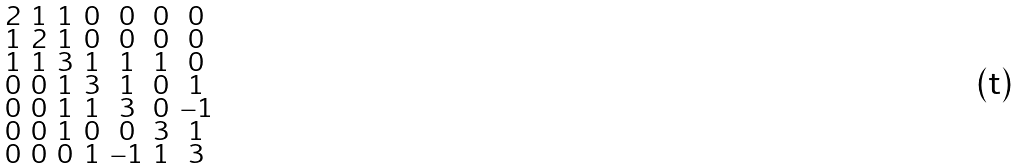<formula> <loc_0><loc_0><loc_500><loc_500>\begin{smallmatrix} 2 & 1 & 1 & 0 & 0 & 0 & 0 \\ 1 & 2 & 1 & 0 & 0 & 0 & 0 \\ 1 & 1 & 3 & 1 & 1 & 1 & 0 \\ 0 & 0 & 1 & 3 & 1 & 0 & 1 \\ 0 & 0 & 1 & 1 & 3 & 0 & - 1 \\ 0 & 0 & 1 & 0 & 0 & 3 & 1 \\ 0 & 0 & 0 & 1 & - 1 & 1 & 3 \end{smallmatrix}</formula> 